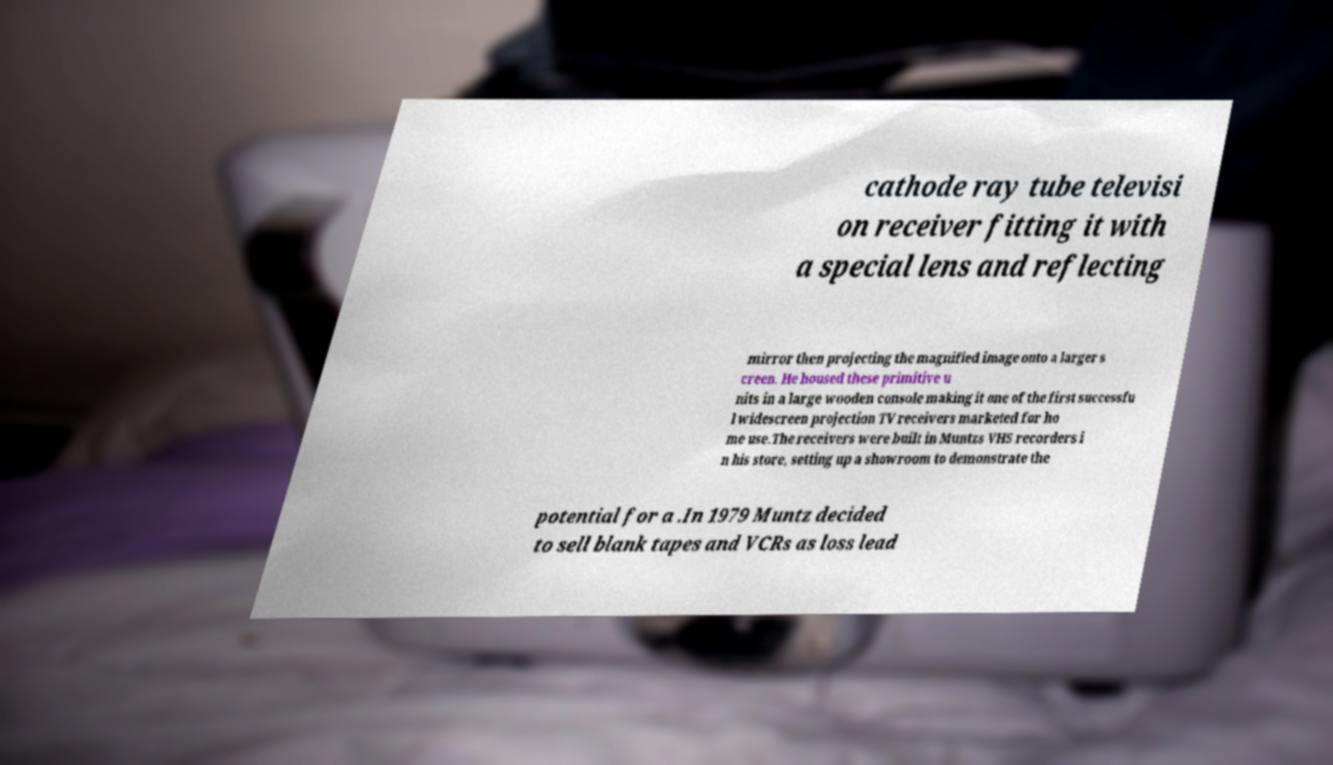Please identify and transcribe the text found in this image. cathode ray tube televisi on receiver fitting it with a special lens and reflecting mirror then projecting the magnified image onto a larger s creen. He housed these primitive u nits in a large wooden console making it one of the first successfu l widescreen projection TV receivers marketed for ho me use.The receivers were built in Muntzs VHS recorders i n his store, setting up a showroom to demonstrate the potential for a .In 1979 Muntz decided to sell blank tapes and VCRs as loss lead 